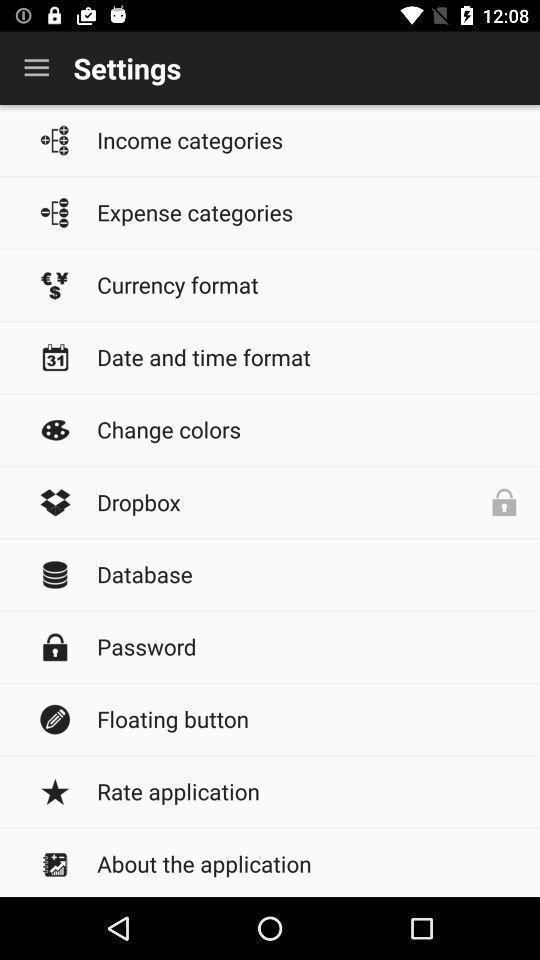Please provide a description for this image. Settings page of an expenses and income app. 